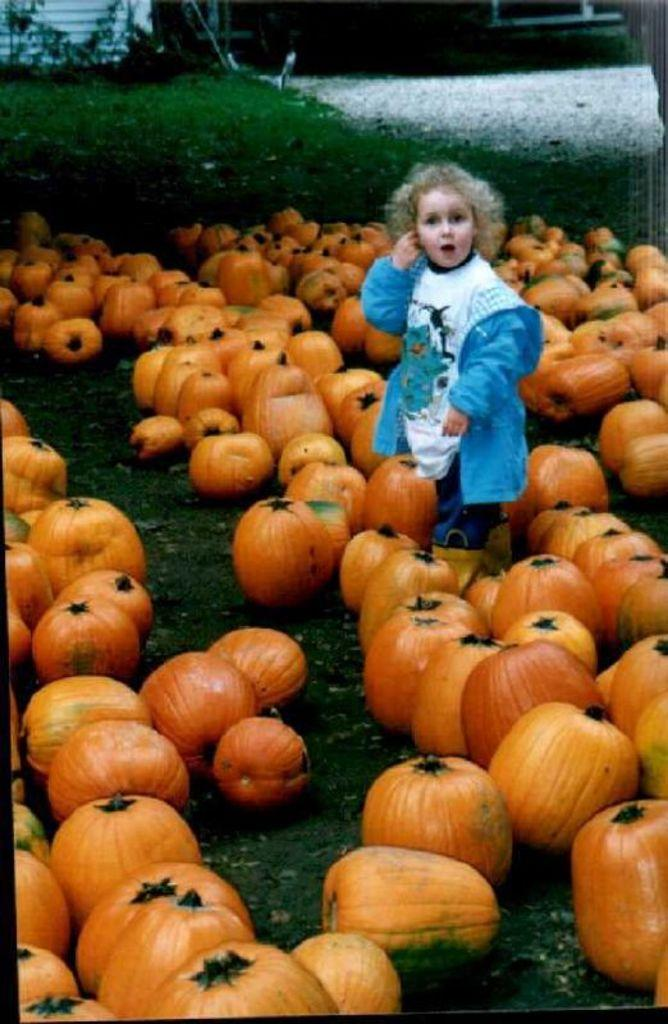Who is the main subject in the picture? There is a girl in the picture. What is the girl standing between? The girl is standing between pumpkins. Where are the pumpkins located? The pumpkins are on the grass. What type of toys can be seen on the throne in the image? There is no throne or toys present in the image; it features a girl standing between pumpkins on the grass. 